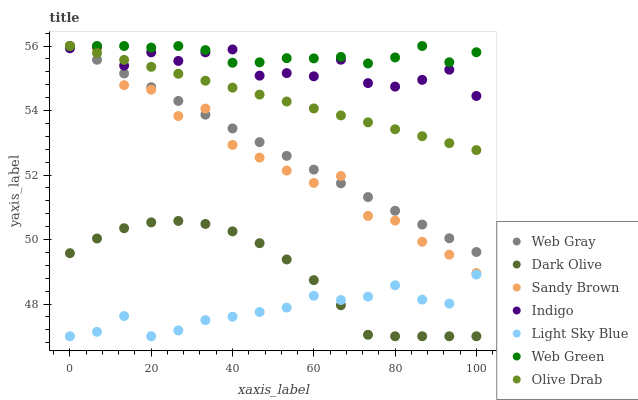Does Light Sky Blue have the minimum area under the curve?
Answer yes or no. Yes. Does Web Green have the maximum area under the curve?
Answer yes or no. Yes. Does Indigo have the minimum area under the curve?
Answer yes or no. No. Does Indigo have the maximum area under the curve?
Answer yes or no. No. Is Web Gray the smoothest?
Answer yes or no. Yes. Is Sandy Brown the roughest?
Answer yes or no. Yes. Is Indigo the smoothest?
Answer yes or no. No. Is Indigo the roughest?
Answer yes or no. No. Does Dark Olive have the lowest value?
Answer yes or no. Yes. Does Indigo have the lowest value?
Answer yes or no. No. Does Olive Drab have the highest value?
Answer yes or no. Yes. Does Indigo have the highest value?
Answer yes or no. No. Is Dark Olive less than Olive Drab?
Answer yes or no. Yes. Is Web Gray greater than Light Sky Blue?
Answer yes or no. Yes. Does Web Green intersect Web Gray?
Answer yes or no. Yes. Is Web Green less than Web Gray?
Answer yes or no. No. Is Web Green greater than Web Gray?
Answer yes or no. No. Does Dark Olive intersect Olive Drab?
Answer yes or no. No. 